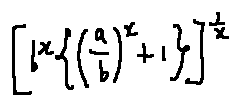<formula> <loc_0><loc_0><loc_500><loc_500>[ b ^ { x } \{ ( \frac { a } { b } ) ^ { x } + 1 \} ] ^ { \frac { 1 } { x } }</formula> 